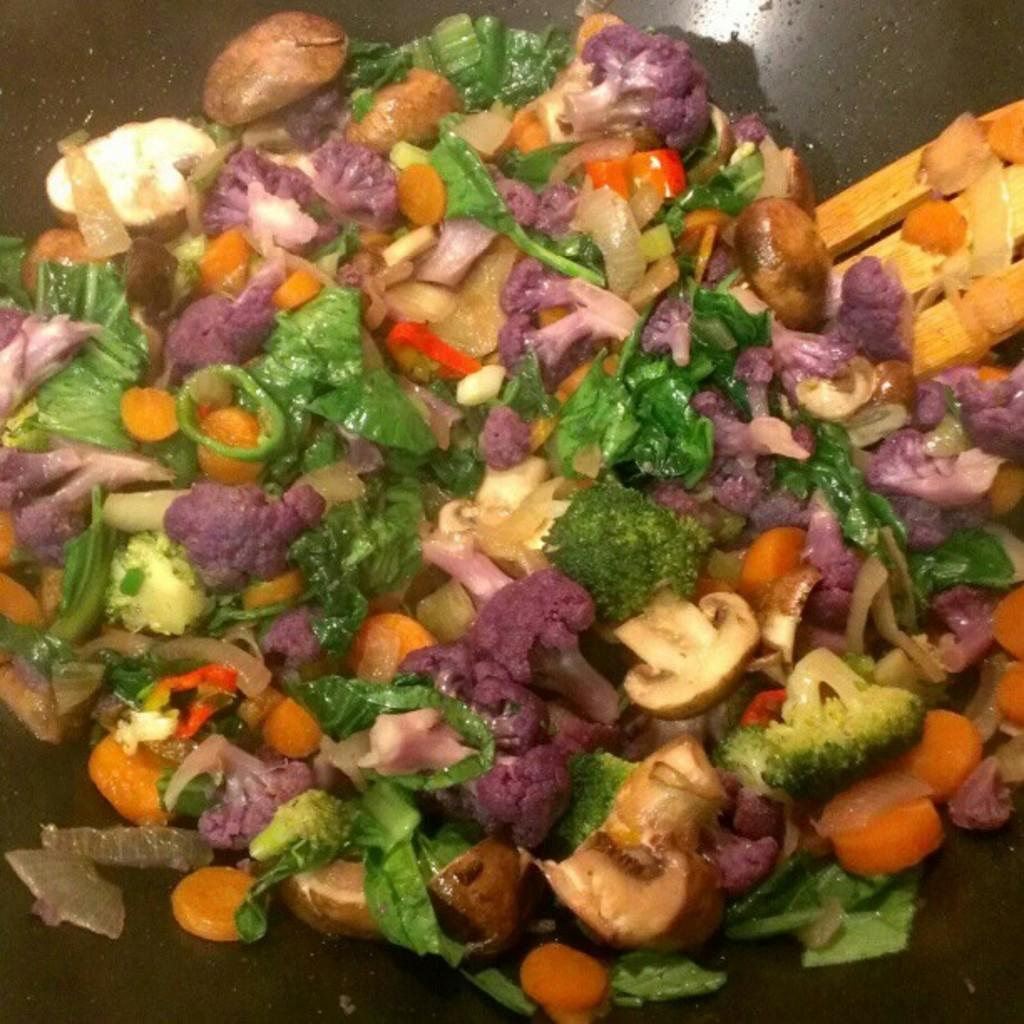What type of pan is visible in the image? The image contains a black pan. What is inside the pan? There are food items in the pan. What utensil is present in the image? There is a wooden spatula in the image. What type of quartz can be seen in the image? There is no quartz present in the image; it features a black pan with food items and a wooden spatula. 